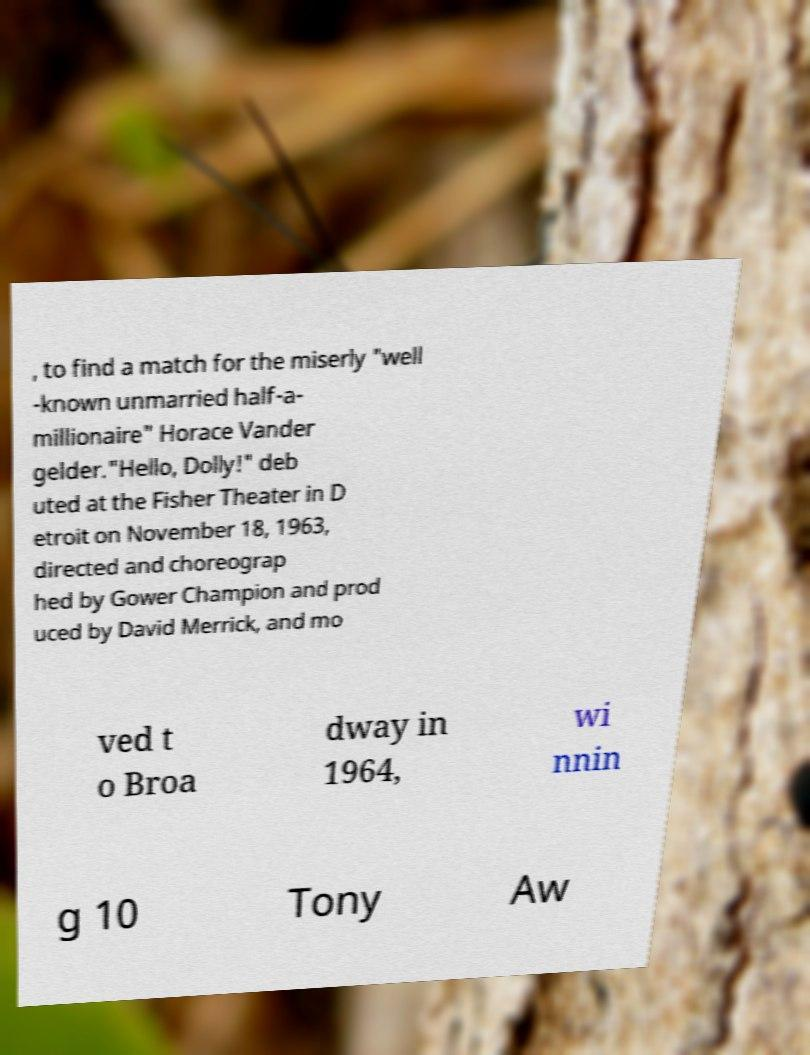Please identify and transcribe the text found in this image. , to find a match for the miserly "well -known unmarried half-a- millionaire" Horace Vander gelder."Hello, Dolly!" deb uted at the Fisher Theater in D etroit on November 18, 1963, directed and choreograp hed by Gower Champion and prod uced by David Merrick, and mo ved t o Broa dway in 1964, wi nnin g 10 Tony Aw 